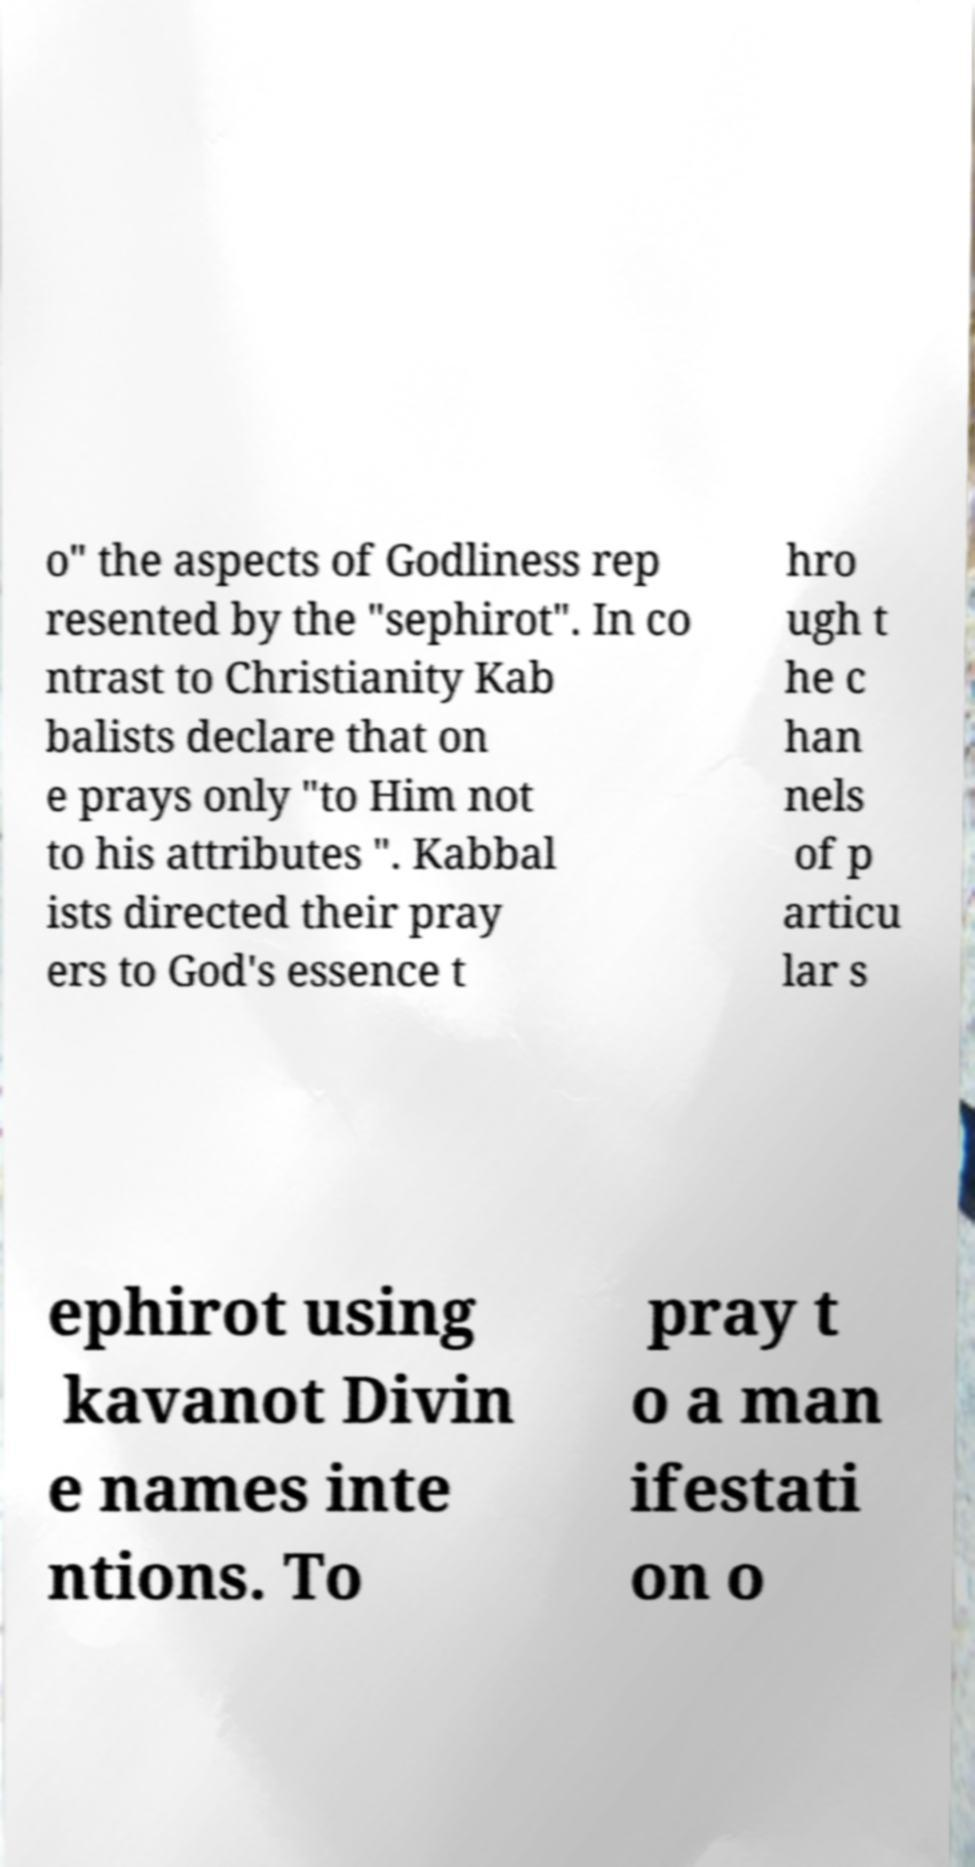Please identify and transcribe the text found in this image. o" the aspects of Godliness rep resented by the "sephirot". In co ntrast to Christianity Kab balists declare that on e prays only "to Him not to his attributes ". Kabbal ists directed their pray ers to God's essence t hro ugh t he c han nels of p articu lar s ephirot using kavanot Divin e names inte ntions. To pray t o a man ifestati on o 